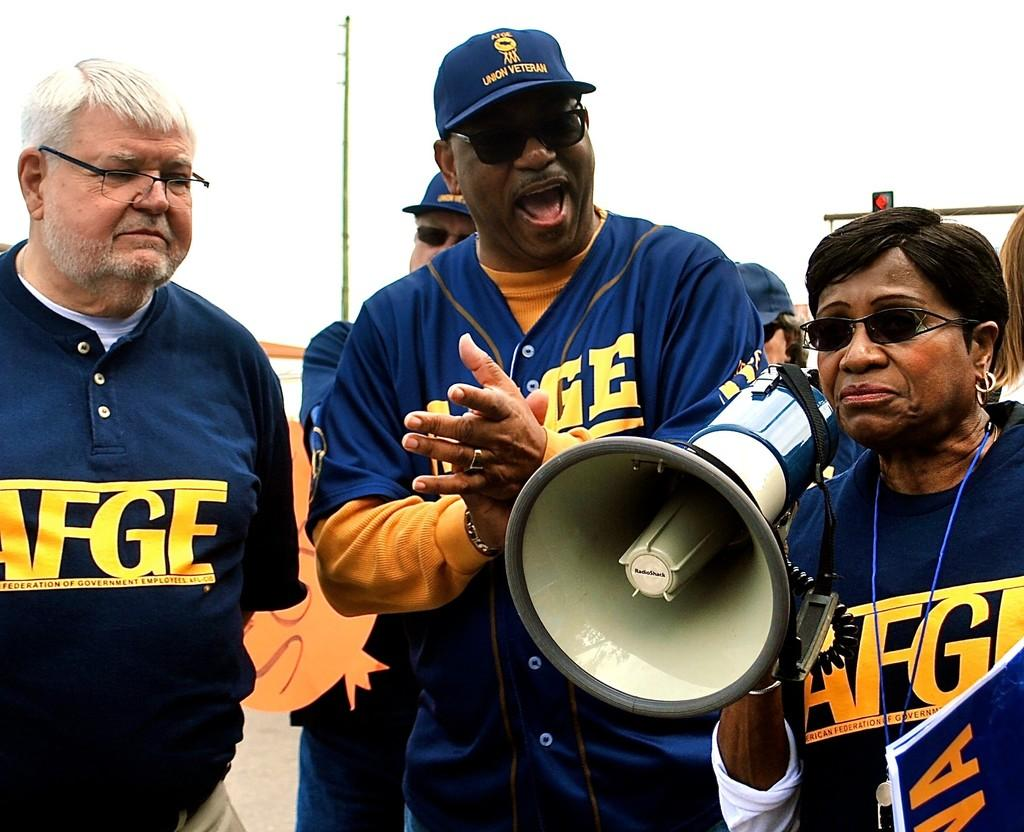Provide a one-sentence caption for the provided image. A group of American Federation of Government Employees gather together. 